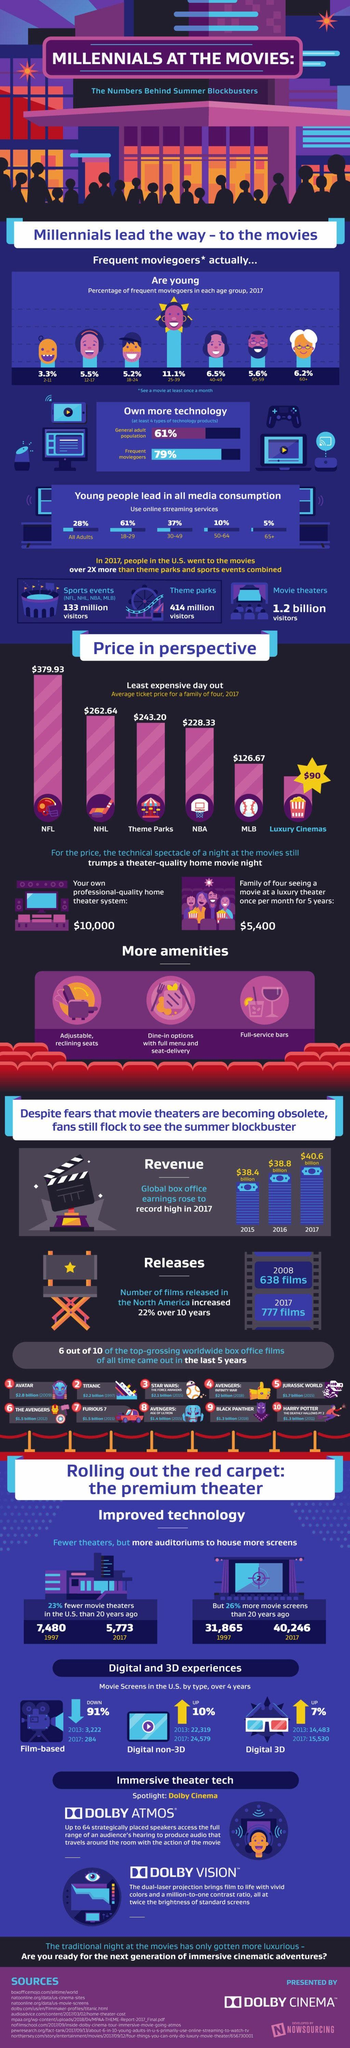Give some essential details in this illustration. A significant percentage of senior citizens go to the movies, with 6.2% being the specific figure. The difference in price between NFL and NHL is $117.29. In 2017, the revenue amounted to $40.6 billion. Frequent moviegoers tend to own more technology than those who do not go to the movies as often. The information means that frequent moviegoers are individuals who watch movies at least once a month. 